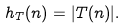Convert formula to latex. <formula><loc_0><loc_0><loc_500><loc_500>h _ { T } ( n ) = | T ( n ) | .</formula> 